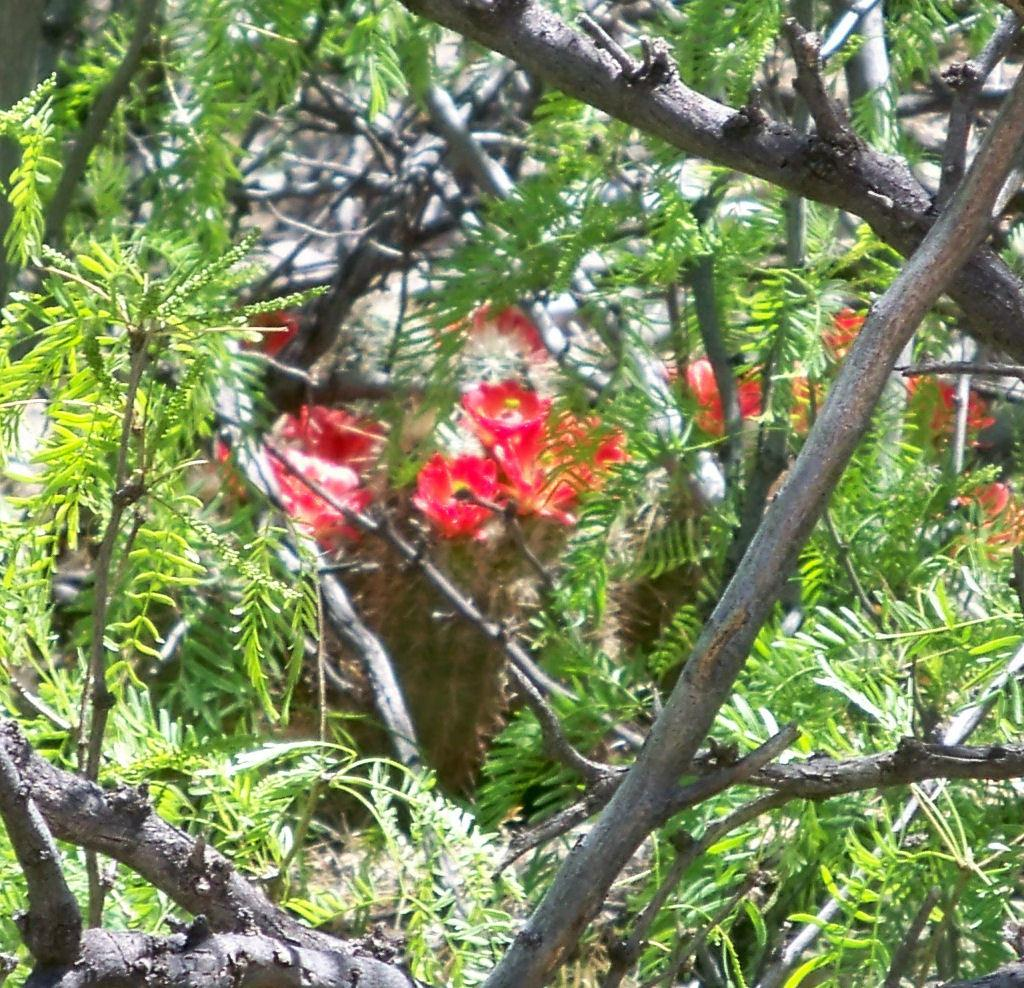What type of vegetation can be seen in the image? There are trees in the image. What color are the flowers in the image? The flowers in the image are red. How would you describe the background of the image? The background of the image is brown and white in color. How many beans are hanging from the trees in the image? There are no beans present in the image; it features trees and red flowers. What type of ray can be seen flying in the image? There is no ray present in the image; it only features trees, red flowers, and a brown and white background. 